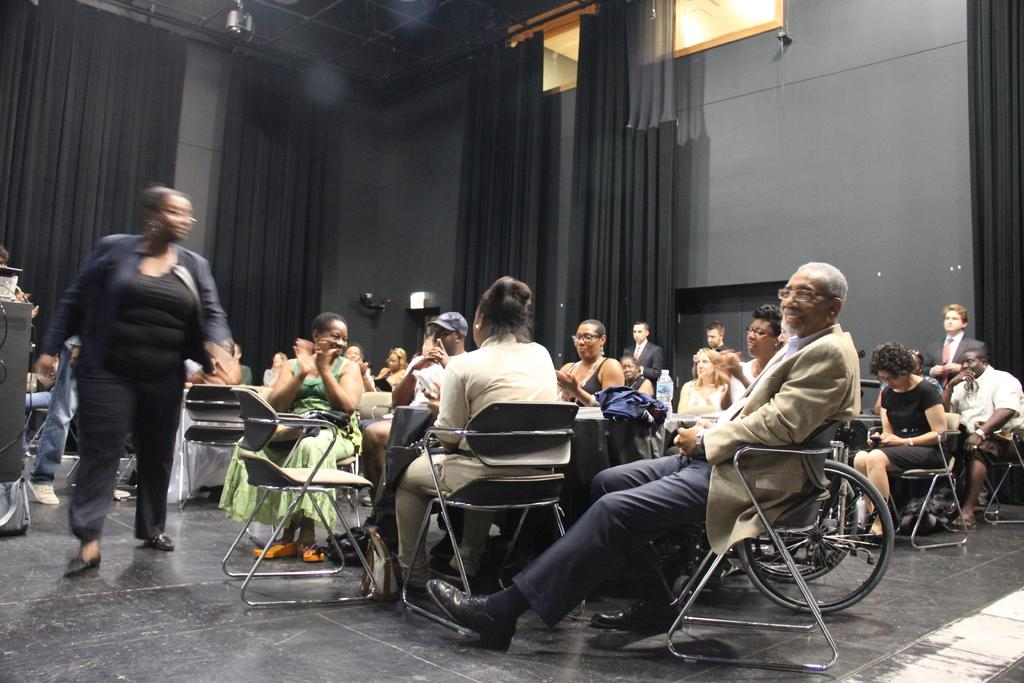What are the people in the image doing? There is a group of people sitting on chairs in the image. What is the person in the image doing who is not sitting on a chair? There is a person walking on the floor in the image. What can be seen on the table in the image? There is a bottle visible in the image. What is the background of the image composed of? There are curtains and walls in the background of the image. Can you describe any unspecified objects in the image? There are some unspecified objects in the image, but their details are not provided. How many frogs are hopping on the table in the image? There are no frogs present in the image; it only features a group of people sitting on chairs, a person walking on the floor, a bottle on the table, and unspecified objects. What type of loaf is being served to the people in the image? There is no loaf present in the image. 